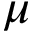<formula> <loc_0><loc_0><loc_500><loc_500>\mu</formula> 